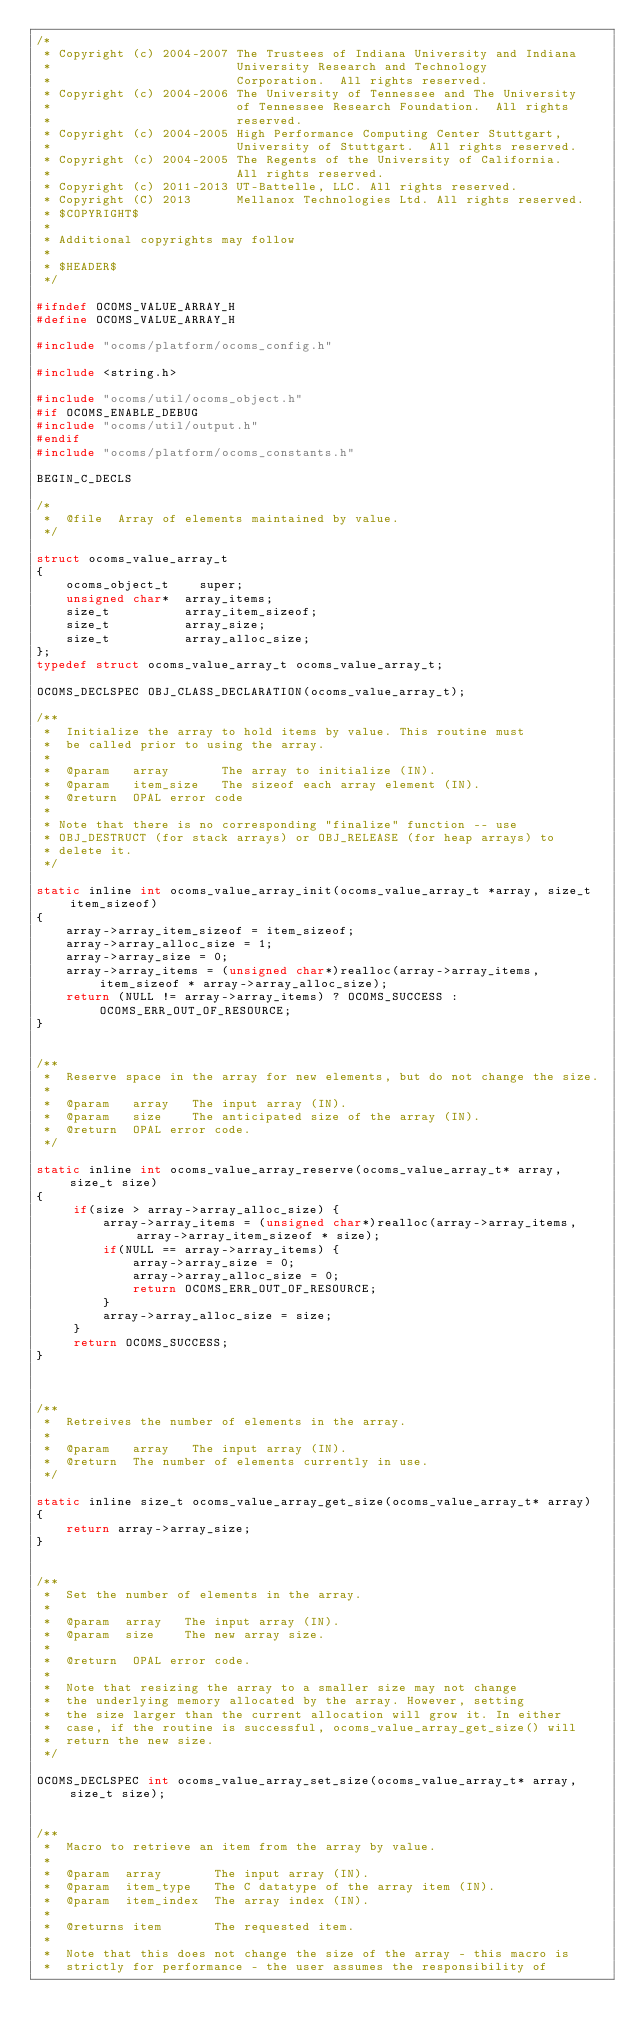Convert code to text. <code><loc_0><loc_0><loc_500><loc_500><_C_>/*
 * Copyright (c) 2004-2007 The Trustees of Indiana University and Indiana
 *                         University Research and Technology
 *                         Corporation.  All rights reserved.
 * Copyright (c) 2004-2006 The University of Tennessee and The University
 *                         of Tennessee Research Foundation.  All rights
 *                         reserved.
 * Copyright (c) 2004-2005 High Performance Computing Center Stuttgart, 
 *                         University of Stuttgart.  All rights reserved.
 * Copyright (c) 2004-2005 The Regents of the University of California.
 *                         All rights reserved.
 * Copyright (c) 2011-2013 UT-Battelle, LLC. All rights reserved.
 * Copyright (C) 2013      Mellanox Technologies Ltd. All rights reserved.
 * $COPYRIGHT$
 * 
 * Additional copyrights may follow
 * 
 * $HEADER$
 */

#ifndef OCOMS_VALUE_ARRAY_H
#define OCOMS_VALUE_ARRAY_H

#include "ocoms/platform/ocoms_config.h"

#include <string.h>

#include "ocoms/util/ocoms_object.h"
#if OCOMS_ENABLE_DEBUG
#include "ocoms/util/output.h"
#endif
#include "ocoms/platform/ocoms_constants.h"

BEGIN_C_DECLS

/*
 *  @file  Array of elements maintained by value.
 */

struct ocoms_value_array_t
{
    ocoms_object_t    super;
    unsigned char*  array_items;
    size_t          array_item_sizeof;
    size_t          array_size;
    size_t          array_alloc_size;
};
typedef struct ocoms_value_array_t ocoms_value_array_t;

OCOMS_DECLSPEC OBJ_CLASS_DECLARATION(ocoms_value_array_t);

/**
 *  Initialize the array to hold items by value. This routine must 
 *  be called prior to using the array.
 *
 *  @param   array       The array to initialize (IN).
 *  @param   item_size   The sizeof each array element (IN).
 *  @return  OPAL error code
 *
 * Note that there is no corresponding "finalize" function -- use
 * OBJ_DESTRUCT (for stack arrays) or OBJ_RELEASE (for heap arrays) to
 * delete it.
 */

static inline int ocoms_value_array_init(ocoms_value_array_t *array, size_t item_sizeof)
{
    array->array_item_sizeof = item_sizeof;
    array->array_alloc_size = 1; 
    array->array_size = 0;
    array->array_items = (unsigned char*)realloc(array->array_items, item_sizeof * array->array_alloc_size);
    return (NULL != array->array_items) ? OCOMS_SUCCESS : OCOMS_ERR_OUT_OF_RESOURCE;
}


/**
 *  Reserve space in the array for new elements, but do not change the size.
 *
 *  @param   array   The input array (IN).
 *  @param   size    The anticipated size of the array (IN).
 *  @return  OPAL error code.
 */

static inline int ocoms_value_array_reserve(ocoms_value_array_t* array, size_t size)
{
     if(size > array->array_alloc_size) {
         array->array_items = (unsigned char*)realloc(array->array_items, array->array_item_sizeof * size);
         if(NULL == array->array_items) {
             array->array_size = 0;
             array->array_alloc_size = 0;
             return OCOMS_ERR_OUT_OF_RESOURCE;
         }
         array->array_alloc_size = size;
     }
     return OCOMS_SUCCESS;
}



/**
 *  Retreives the number of elements in the array.
 *
 *  @param   array   The input array (IN).
 *  @return  The number of elements currently in use.
 */

static inline size_t ocoms_value_array_get_size(ocoms_value_array_t* array)
{
    return array->array_size;
}


/**
 *  Set the number of elements in the array.
 *
 *  @param  array   The input array (IN).
 *  @param  size    The new array size.
 *
 *  @return  OPAL error code.
 *
 *  Note that resizing the array to a smaller size may not change
 *  the underlying memory allocated by the array. However, setting
 *  the size larger than the current allocation will grow it. In either
 *  case, if the routine is successful, ocoms_value_array_get_size() will 
 *  return the new size.
 */

OCOMS_DECLSPEC int ocoms_value_array_set_size(ocoms_value_array_t* array, size_t size);


/** 
 *  Macro to retrieve an item from the array by value. 
 *
 *  @param  array       The input array (IN).
 *  @param  item_type   The C datatype of the array item (IN).
 *  @param  item_index  The array index (IN).
 *
 *  @returns item       The requested item.
 *
 *  Note that this does not change the size of the array - this macro is 
 *  strictly for performance - the user assumes the responsibility of </code> 